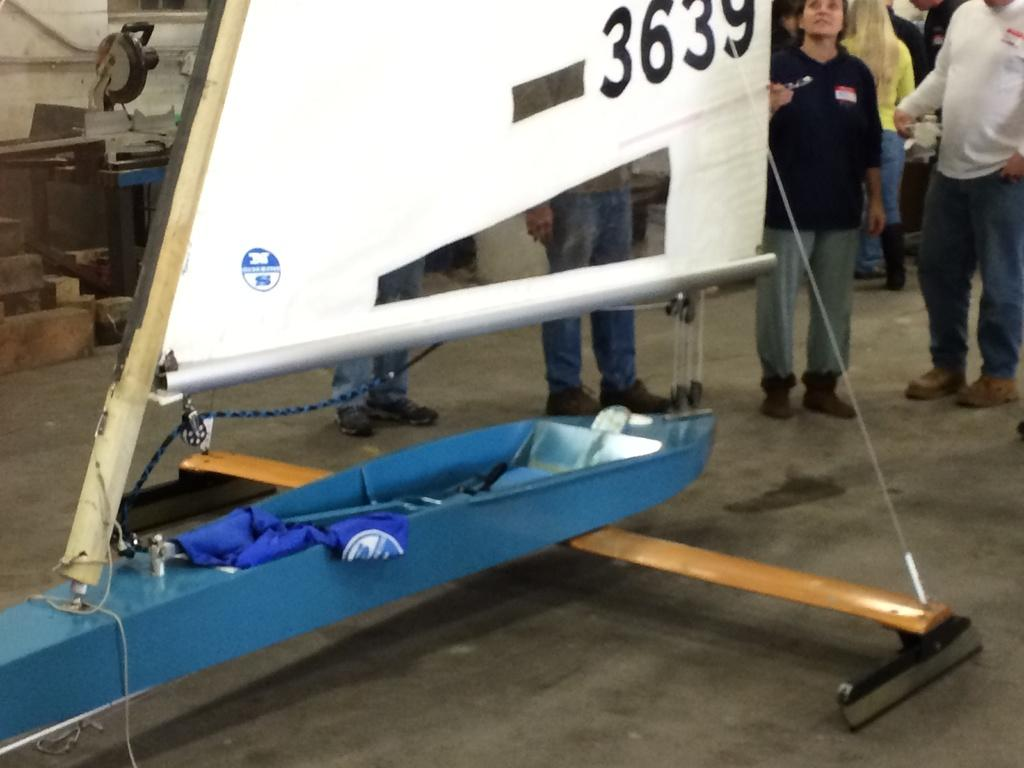<image>
Offer a succinct explanation of the picture presented. An ice glider with a sail and the number 3639 on it 